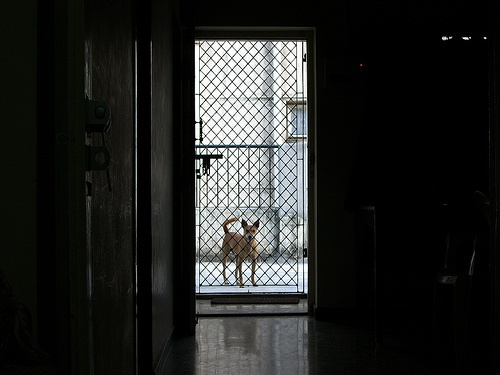Describe the objects in this image and their specific colors. I can see a dog in black, maroon, and gray tones in this image. 